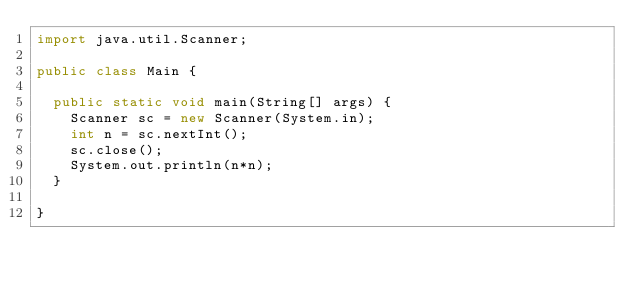Convert code to text. <code><loc_0><loc_0><loc_500><loc_500><_Java_>import java.util.Scanner;

public class Main {

	public static void main(String[] args) {
		Scanner sc = new Scanner(System.in);
		int n = sc.nextInt();
		sc.close();
		System.out.println(n*n);
	}

}</code> 